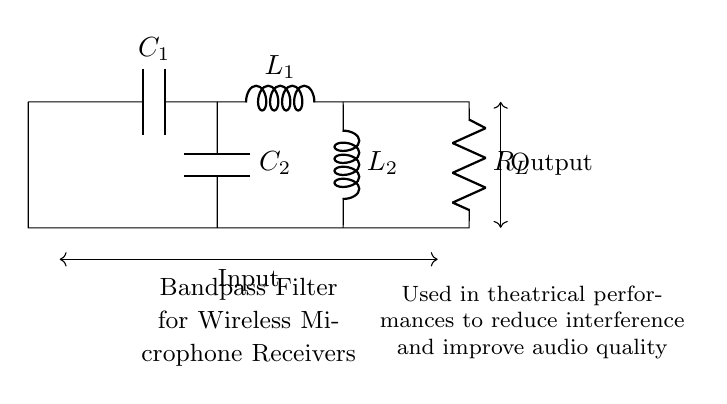What is the total number of capacitors in this circuit? There are two capacitors, labeled as C1 and C2, indicated in the circuit diagram.
Answer: 2 What type of filter is represented in this circuit? The circuit diagram represents a bandpass filter, as stated in the label provided in the diagram.
Answer: Bandpass filter What are the values represented by R, L, and C in this circuit? R refers to the resistor denoted as R_L, L refers to the inductors represented as L1 and L2, and C refers to the capacitors labeled as C1 and C2. Each component is labeled, indicating the specific role in the circuit.
Answer: R_L, L1, L2, C1, C2 Which components are connected in series in this circuit? The components C1, L1, and R_L are connected in series, as they all form a continuous path from the input to output without any branches.
Answer: C1, L1, R_L What is the function of this bandpass filter in theatrical performances? The function of the bandpass filter in this context is to reduce interference from unwanted frequencies and improve the overall audio quality of the wireless microphone receivers used in theatrical performances.
Answer: Improve audio quality How does the bandpass filter affect input and output signals? The bandpass filter will only allow signals within a specific frequency range to pass through while attenuating frequencies outside this range, hence shaping the input signal into a more desirable output.
Answer: Attenuates unwanted frequencies 